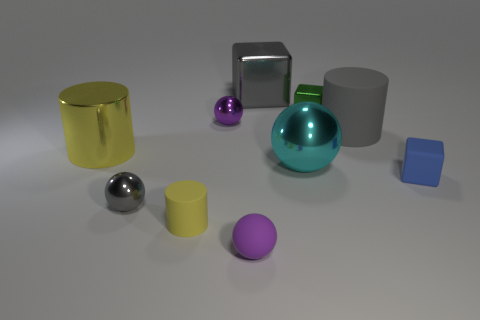How is the lighting affecting the appearance of the objects? The lighting in the image is soft and diffused, creating subtle shadows that give depth to the objects. The reflective surfaces of some objects catch the light and show highlights that indicate the direction of the light source is from above and to the right, giving the scene a calm and even tone. 